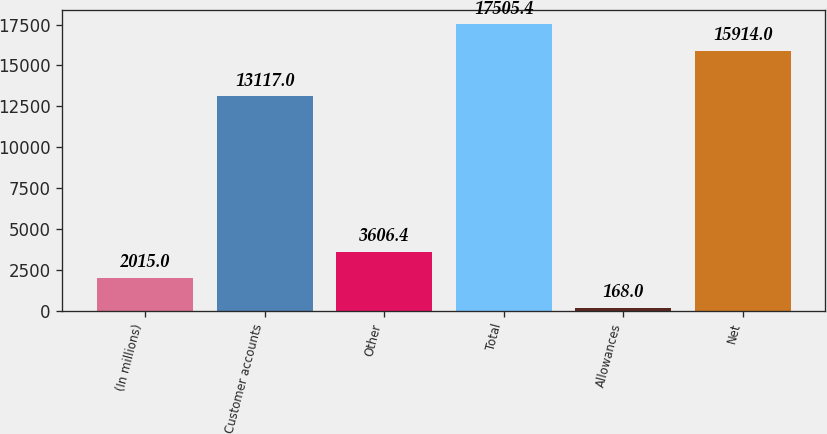Convert chart. <chart><loc_0><loc_0><loc_500><loc_500><bar_chart><fcel>(In millions)<fcel>Customer accounts<fcel>Other<fcel>Total<fcel>Allowances<fcel>Net<nl><fcel>2015<fcel>13117<fcel>3606.4<fcel>17505.4<fcel>168<fcel>15914<nl></chart> 